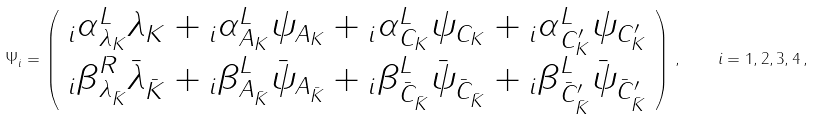Convert formula to latex. <formula><loc_0><loc_0><loc_500><loc_500>\Psi _ { i } = \left ( \begin{array} { c } { _ { i } \alpha } ^ { L } _ { \lambda _ { K } } \lambda _ { K } + { _ { i } \alpha } ^ { L } _ { A _ { K } } \psi _ { A _ { K } } + { _ { i } \alpha } ^ { L } _ { C _ { K } } \psi _ { C _ { K } } + { _ { i } \alpha } ^ { L } _ { C ^ { \prime } _ { K } } \psi _ { C ^ { \prime } _ { K } } \\ { _ { i } \beta } ^ { R } _ { \lambda _ { \bar { K } } } \bar { \lambda } _ { \bar { K } } + { _ { i } \beta } ^ { L } _ { A _ { \bar { K } } } \bar { \psi } _ { A _ { \bar { K } } } + { _ { i } \beta } ^ { L } _ { \bar { C } _ { \bar { K } } } \bar { \psi } _ { \bar { C } _ { \bar { K } } } + { _ { i } \beta } ^ { L } _ { \bar { C } ^ { \prime } _ { \bar { K } } } \bar { \psi } _ { \bar { C } ^ { \prime } _ { \bar { K } } } \end{array} \right ) \, , \quad i = 1 , 2 , 3 , 4 \, ,</formula> 